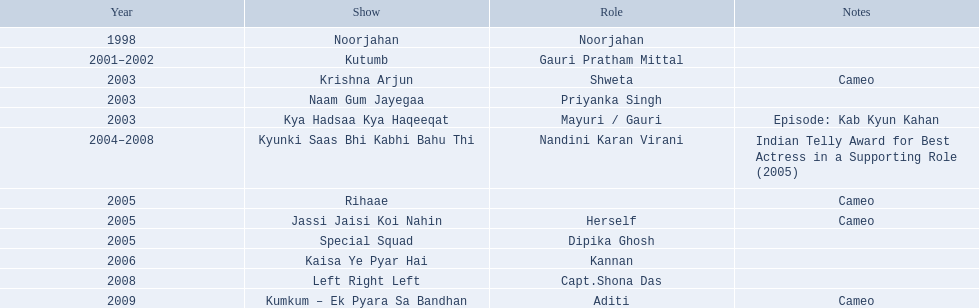The productions including no more than 1 brief appearance Krishna Arjun, Rihaae, Jassi Jaisi Koi Nahin, Kumkum - Ek Pyara Sa Bandhan. 